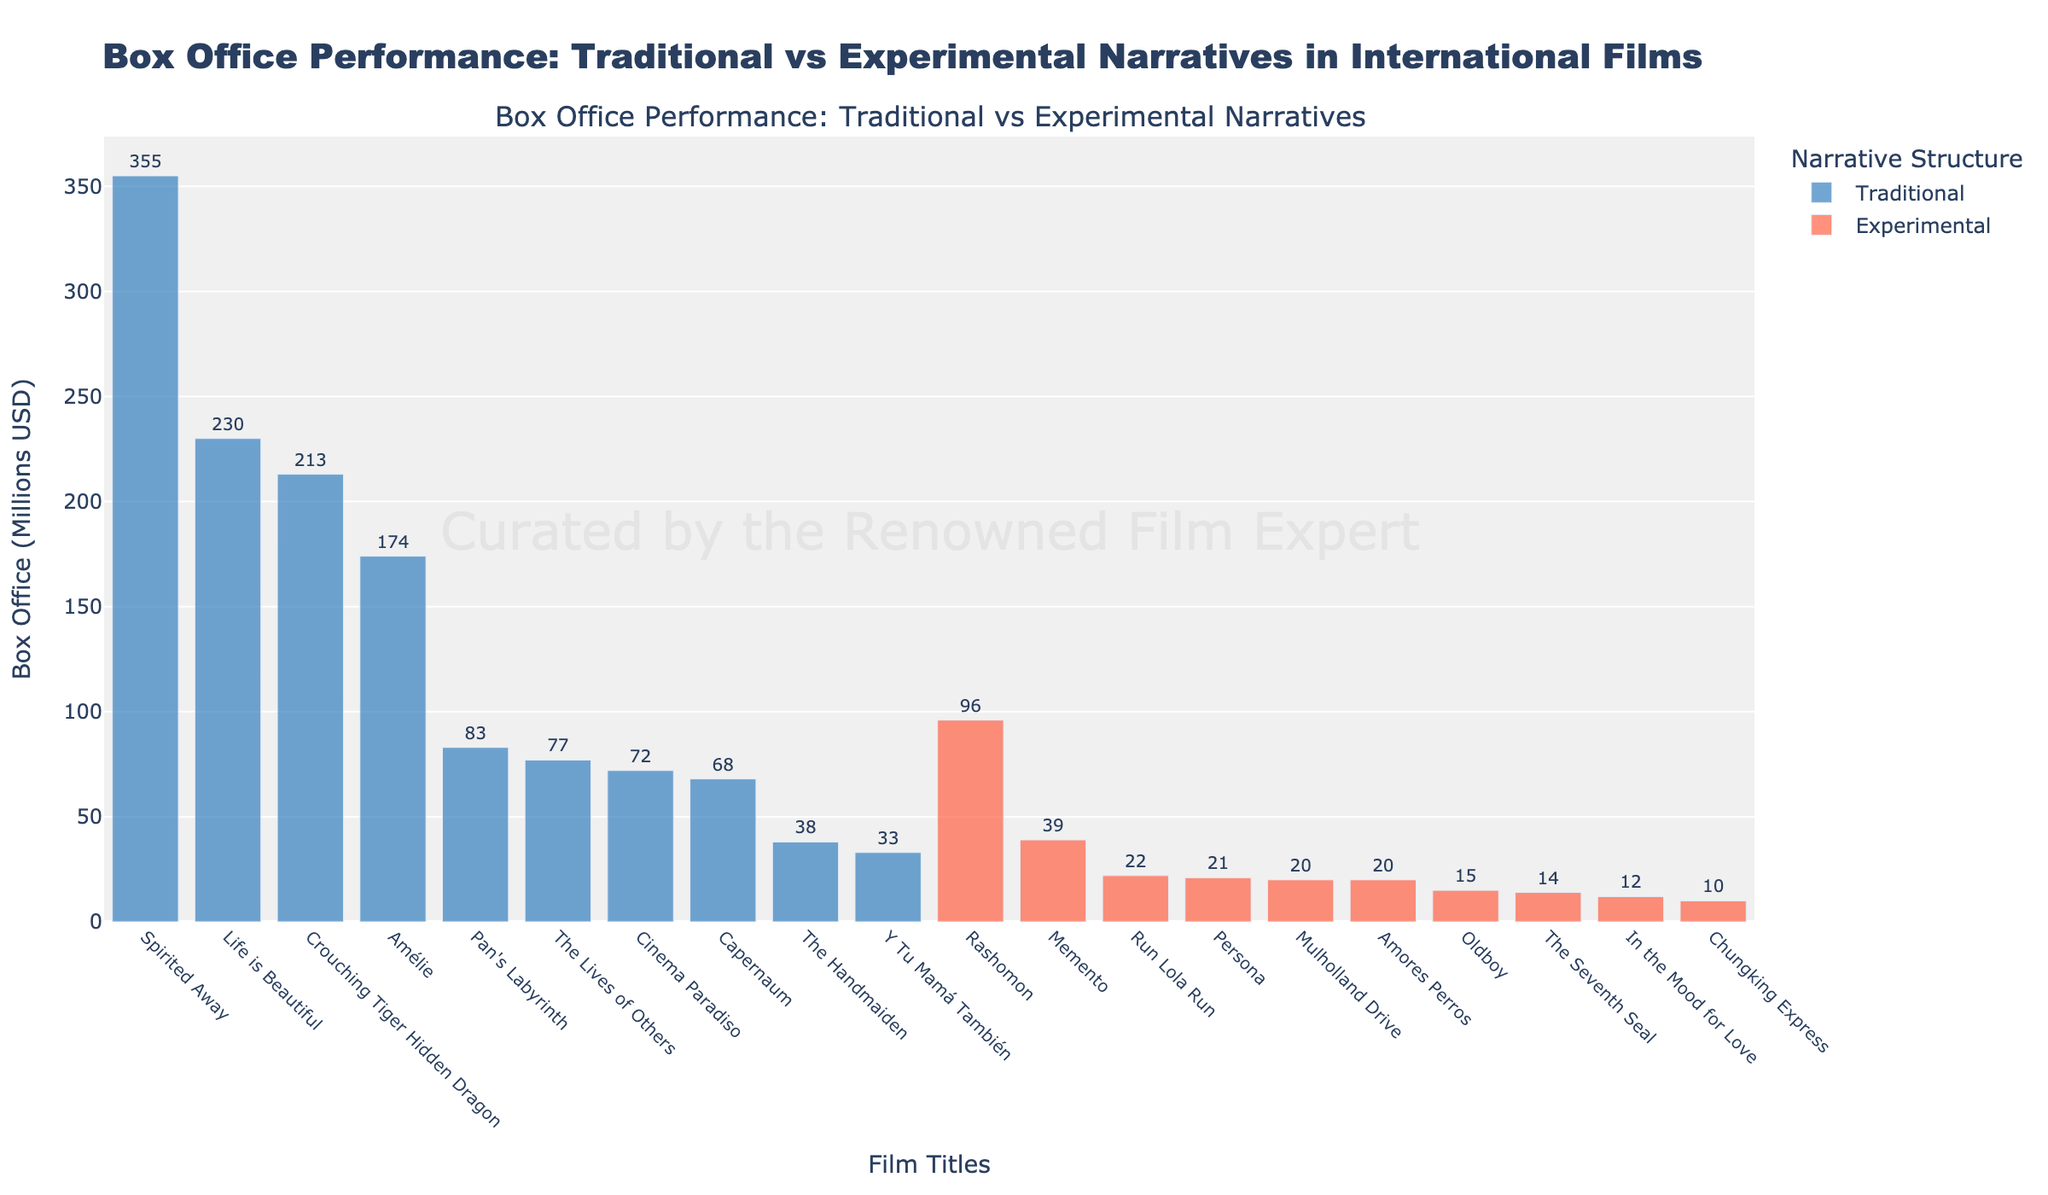Which film has the highest box office revenue among those with a traditional narrative structure? The tallest bar in blue color represents the film with the highest box office revenue among traditional narratives, which is "Spirited Away" with $355 million.
Answer: Spirited Away Which film has the lowest box office revenue among experimental narratives? The shortest bar in red color represents the film with the lowest box office revenue among experimental narratives, which is "Chungking Express" with $10 million.
Answer: Chungking Express What is the total box office revenue for films with traditional narrative structures? Sum the box office revenues of all the films with blue bars: 174 + 72 + 230 + 213 + 77 + 68 + 38 + 355 + 83 = 1310.
Answer: 1310 What is the average box office revenue for films with experimental narrative structures? Calculate the sum of the revenues for red bars: 96 + 22 + 39 + 15 + 20 + 21 + 10 + 20 + 14 + 12 = 269. Divide by the number of experimental films (10). 269 / 10 = 26.9
Answer: 26.9 How does the box office revenue of "Pan's Labyrinth" compare to "Rashomon"? "Pan's Labyrinth" (blue bar) has a box office revenue of $83 million, while "Rashomon" (red bar) has $96 million. "Pan's Labyrinth" made $13 million less.
Answer: Rashomon Which narrative structure, traditional or experimental, has the highest individual box office revenue, and how much is it? "Spirited Away" (blue bar) has the highest individual box office revenue with $355 million among traditional narratives.
Answer: Traditional, $355 million Among the films shown, which has the second-highest box office revenue? The second tallest bar among all bars is "Life is Beautiful" (blue bar) with $230 million.
Answer: Life is Beautiful Compare the combined box office revenues of the top two experimental films to the top two traditional films. The top two experimental films are "Rashomon" ($96M) and "Memento" ($39M), totaling 96 + 39 = $135M. The top two traditional films are "Spirited Away" ($355M) and "Crouching Tiger Hidden Dragon" ($213M), totaling 355 + 213 = $568M. The top two traditional films have a combined total of $433M more.
Answer: $433M more Which film has a box office revenue closest to $50 million? Find the bars with the closest values and check their box office revenues. "The Handmaiden" (blue bar) has $38 million, which is the closest to $50 million.
Answer: The Handmaiden How much more box office revenue does "The Lives of Others" have compared to "In the Mood for Love"? Subtract the box office revenue of "In the Mood for Love" (red bar, $12 million) from "The Lives of Others" (blue bar, $77 million): 77 - 12 = 65.
Answer: $65 million 